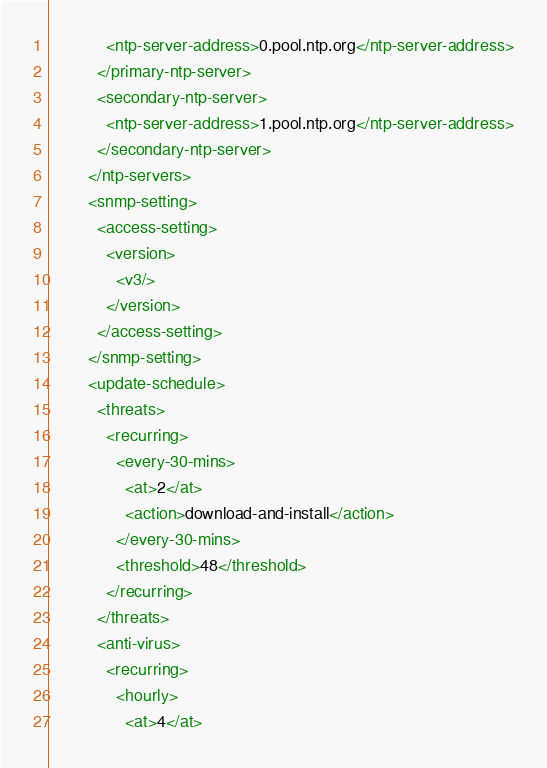Convert code to text. <code><loc_0><loc_0><loc_500><loc_500><_XML_>            <ntp-server-address>0.pool.ntp.org</ntp-server-address>
          </primary-ntp-server>
          <secondary-ntp-server>
            <ntp-server-address>1.pool.ntp.org</ntp-server-address>
          </secondary-ntp-server>
        </ntp-servers>
        <snmp-setting>
          <access-setting>
            <version>
              <v3/>
            </version>
          </access-setting>
        </snmp-setting>
        <update-schedule>
          <threats>
            <recurring>
              <every-30-mins>
                <at>2</at>
                <action>download-and-install</action>
              </every-30-mins>
              <threshold>48</threshold>
            </recurring>
          </threats>
          <anti-virus>
            <recurring>
              <hourly>
                <at>4</at></code> 